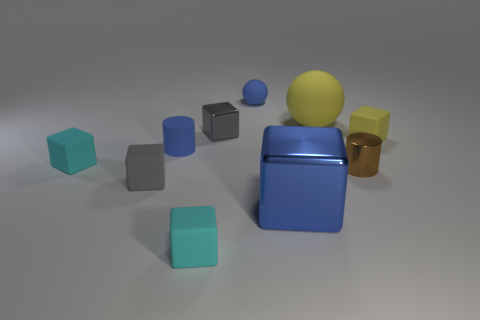Is there an object in the image that stands out due to its texture or material? Yes, the golden cylinder stands out due to its shiny reflective surface compared to the matte textures of the surrounding cubes and the more diffused reflection of the sphere. 